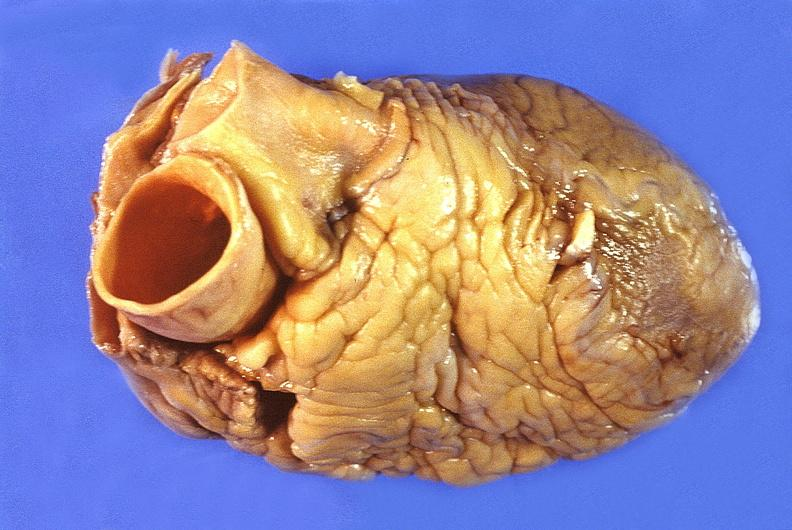where is this?
Answer the question using a single word or phrase. Heart 